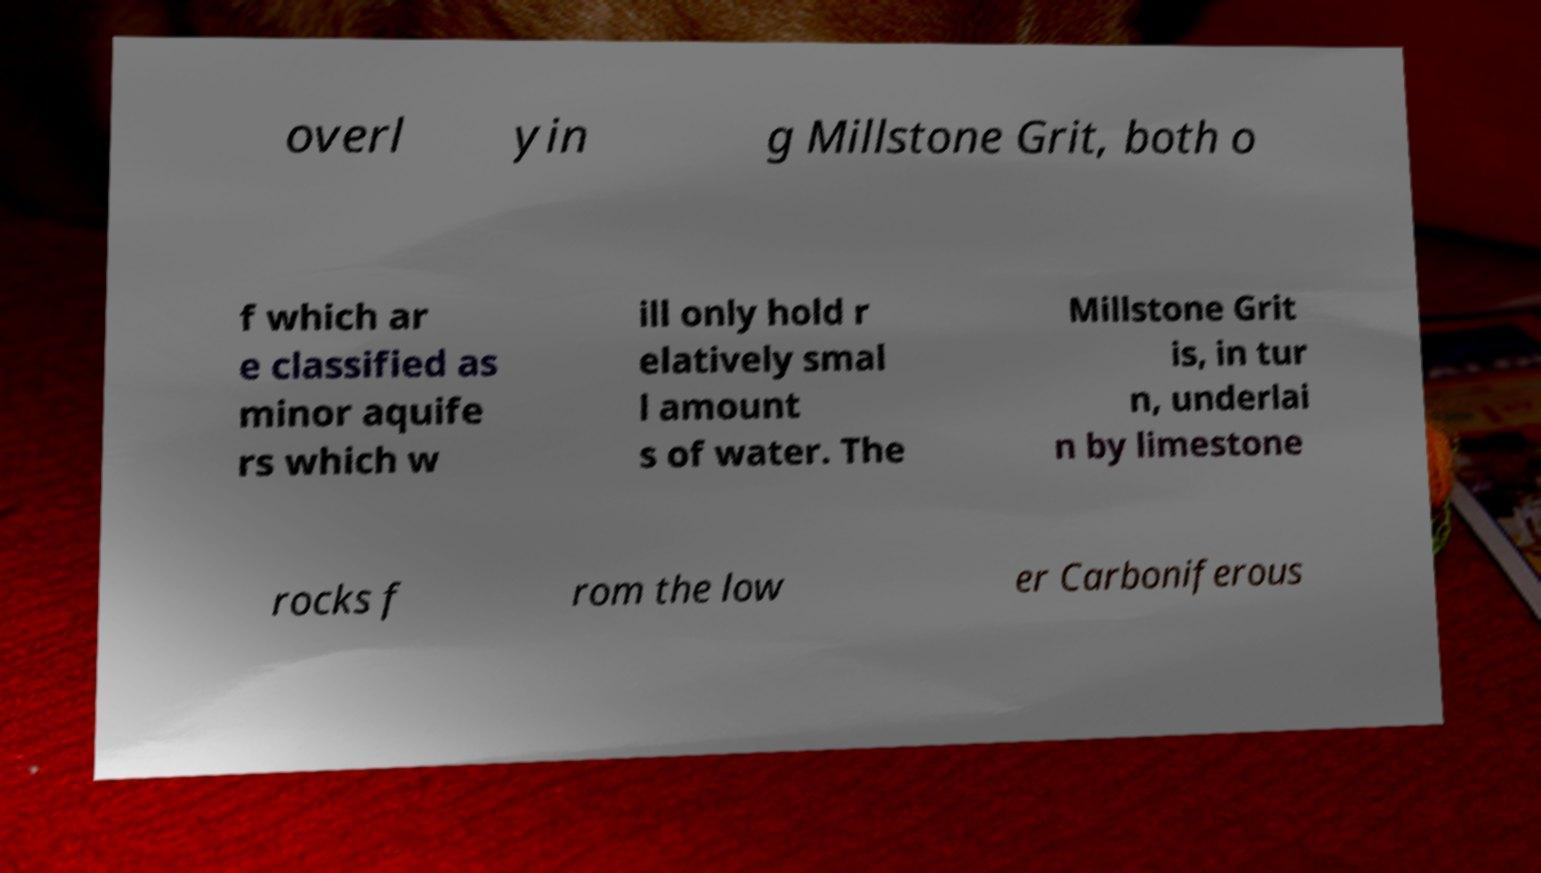Can you accurately transcribe the text from the provided image for me? overl yin g Millstone Grit, both o f which ar e classified as minor aquife rs which w ill only hold r elatively smal l amount s of water. The Millstone Grit is, in tur n, underlai n by limestone rocks f rom the low er Carboniferous 